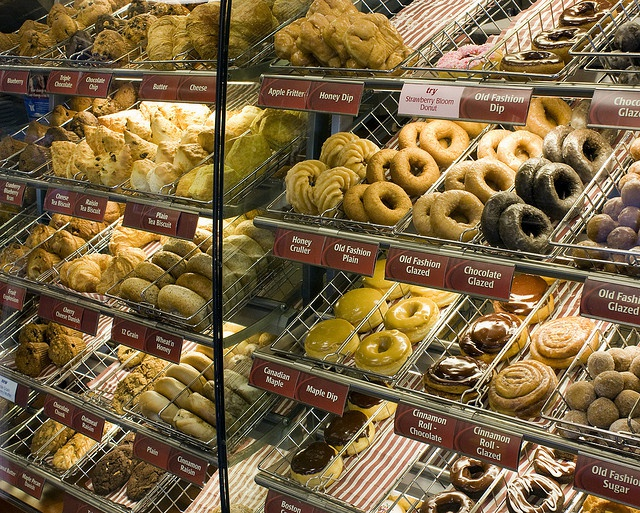Describe the objects in this image and their specific colors. I can see donut in black, olive, tan, and gray tones, donut in black, olive, and tan tones, donut in black, olive, and orange tones, donut in black, orange, gold, and olive tones, and donut in black, orange, maroon, and tan tones in this image. 